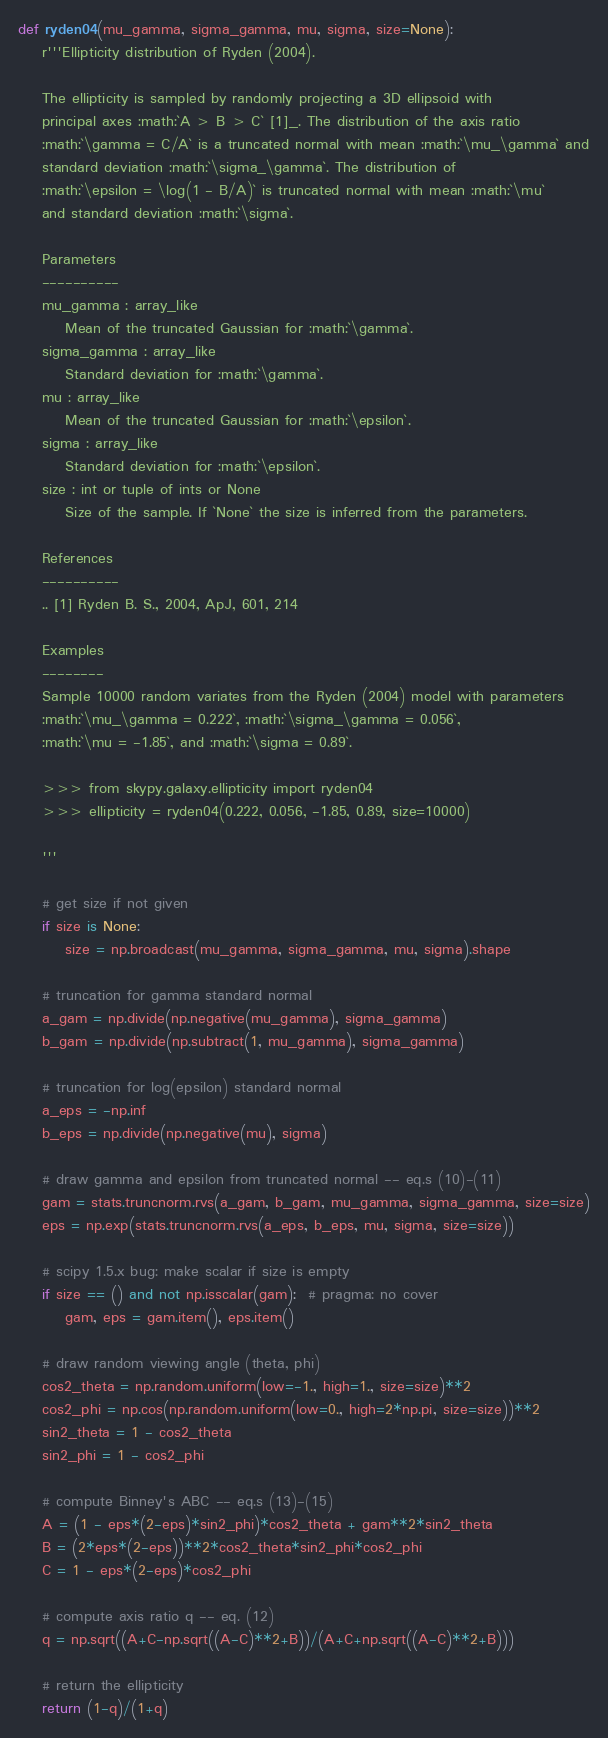<code> <loc_0><loc_0><loc_500><loc_500><_Python_>def ryden04(mu_gamma, sigma_gamma, mu, sigma, size=None):
    r'''Ellipticity distribution of Ryden (2004).

    The ellipticity is sampled by randomly projecting a 3D ellipsoid with
    principal axes :math:`A > B > C` [1]_. The distribution of the axis ratio
    :math:`\gamma = C/A` is a truncated normal with mean :math:`\mu_\gamma` and
    standard deviation :math:`\sigma_\gamma`. The distribution of
    :math:`\epsilon = \log(1 - B/A)` is truncated normal with mean :math:`\mu`
    and standard deviation :math:`\sigma`.

    Parameters
    ----------
    mu_gamma : array_like
        Mean of the truncated Gaussian for :math:`\gamma`.
    sigma_gamma : array_like
        Standard deviation for :math:`\gamma`.
    mu : array_like
        Mean of the truncated Gaussian for :math:`\epsilon`.
    sigma : array_like
        Standard deviation for :math:`\epsilon`.
    size : int or tuple of ints or None
        Size of the sample. If `None` the size is inferred from the parameters.

    References
    ----------
    .. [1] Ryden B. S., 2004, ApJ, 601, 214

    Examples
    --------
    Sample 10000 random variates from the Ryden (2004) model with parameters
    :math:`\mu_\gamma = 0.222`, :math:`\sigma_\gamma = 0.056`,
    :math:`\mu = -1.85`, and :math:`\sigma = 0.89`.

    >>> from skypy.galaxy.ellipticity import ryden04
    >>> ellipticity = ryden04(0.222, 0.056, -1.85, 0.89, size=10000)

    '''

    # get size if not given
    if size is None:
        size = np.broadcast(mu_gamma, sigma_gamma, mu, sigma).shape

    # truncation for gamma standard normal
    a_gam = np.divide(np.negative(mu_gamma), sigma_gamma)
    b_gam = np.divide(np.subtract(1, mu_gamma), sigma_gamma)

    # truncation for log(epsilon) standard normal
    a_eps = -np.inf
    b_eps = np.divide(np.negative(mu), sigma)

    # draw gamma and epsilon from truncated normal -- eq.s (10)-(11)
    gam = stats.truncnorm.rvs(a_gam, b_gam, mu_gamma, sigma_gamma, size=size)
    eps = np.exp(stats.truncnorm.rvs(a_eps, b_eps, mu, sigma, size=size))

    # scipy 1.5.x bug: make scalar if size is empty
    if size == () and not np.isscalar(gam):  # pragma: no cover
        gam, eps = gam.item(), eps.item()

    # draw random viewing angle (theta, phi)
    cos2_theta = np.random.uniform(low=-1., high=1., size=size)**2
    cos2_phi = np.cos(np.random.uniform(low=0., high=2*np.pi, size=size))**2
    sin2_theta = 1 - cos2_theta
    sin2_phi = 1 - cos2_phi

    # compute Binney's ABC -- eq.s (13)-(15)
    A = (1 - eps*(2-eps)*sin2_phi)*cos2_theta + gam**2*sin2_theta
    B = (2*eps*(2-eps))**2*cos2_theta*sin2_phi*cos2_phi
    C = 1 - eps*(2-eps)*cos2_phi

    # compute axis ratio q -- eq. (12)
    q = np.sqrt((A+C-np.sqrt((A-C)**2+B))/(A+C+np.sqrt((A-C)**2+B)))

    # return the ellipticity
    return (1-q)/(1+q)
</code> 